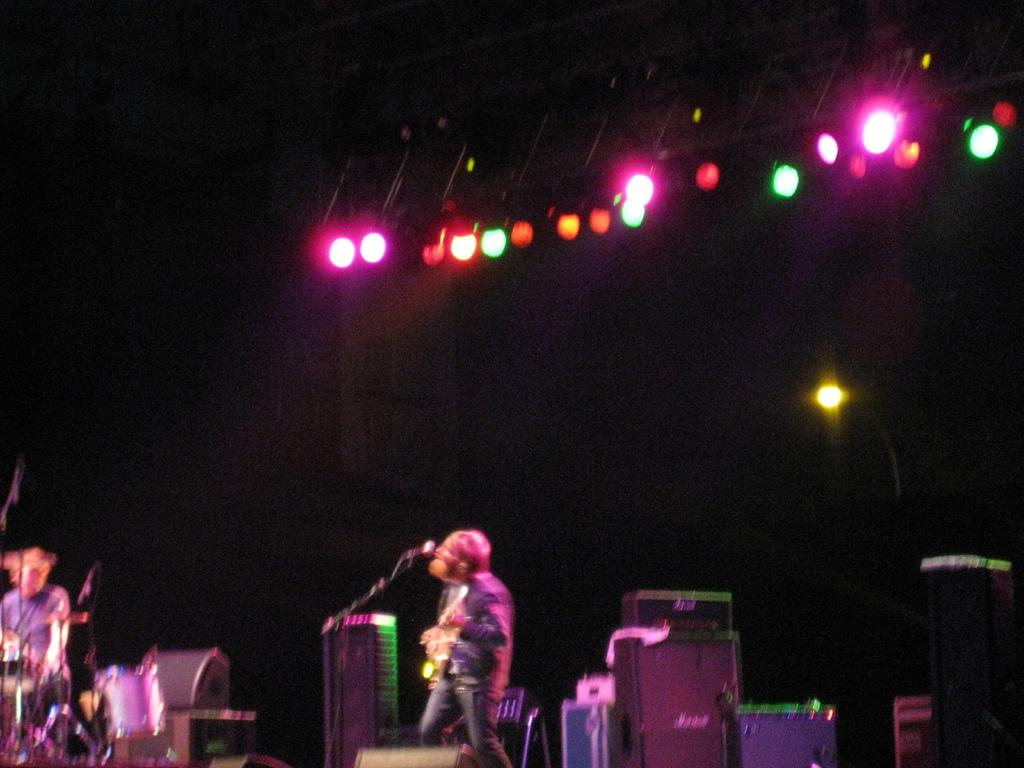How many people are in the image? There are people in the image, but the exact number is not specified. What is one person doing in the image? One person is standing in the image. What is the other person doing in the image? The other person is sitting next to a drum set in the image. What object is present for amplifying sound in the image? There is a mic in the image. What can be seen providing illumination in the image? There are lights in the image. What type of jelly can be seen on the bed in the image? There is no jelly or bed present in the image. How many steps are visible in the image? There is no mention of steps in the image. 